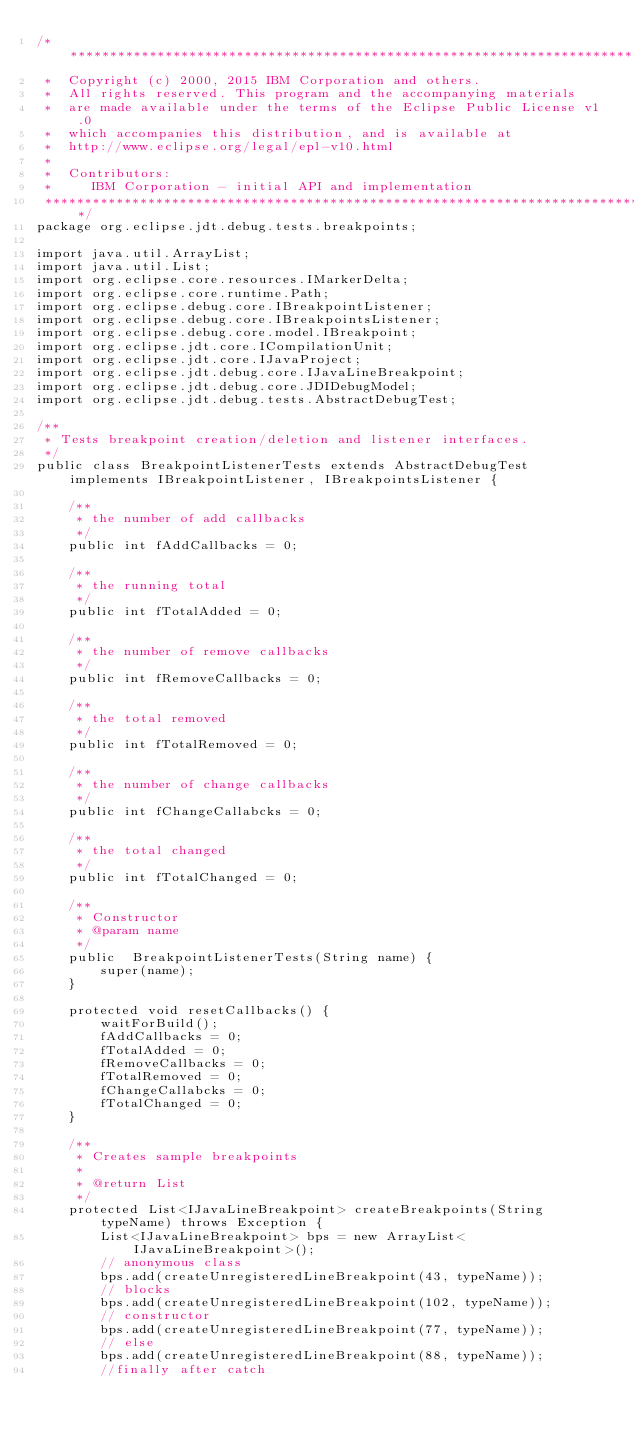<code> <loc_0><loc_0><loc_500><loc_500><_Java_>/*******************************************************************************
 *  Copyright (c) 2000, 2015 IBM Corporation and others.
 *  All rights reserved. This program and the accompanying materials
 *  are made available under the terms of the Eclipse Public License v1.0
 *  which accompanies this distribution, and is available at
 *  http://www.eclipse.org/legal/epl-v10.html
 * 
 *  Contributors:
 *     IBM Corporation - initial API and implementation
 *******************************************************************************/
package org.eclipse.jdt.debug.tests.breakpoints;

import java.util.ArrayList;
import java.util.List;
import org.eclipse.core.resources.IMarkerDelta;
import org.eclipse.core.runtime.Path;
import org.eclipse.debug.core.IBreakpointListener;
import org.eclipse.debug.core.IBreakpointsListener;
import org.eclipse.debug.core.model.IBreakpoint;
import org.eclipse.jdt.core.ICompilationUnit;
import org.eclipse.jdt.core.IJavaProject;
import org.eclipse.jdt.debug.core.IJavaLineBreakpoint;
import org.eclipse.jdt.debug.core.JDIDebugModel;
import org.eclipse.jdt.debug.tests.AbstractDebugTest;

/**
 * Tests breakpoint creation/deletion and listener interfaces.
 */
public class BreakpointListenerTests extends AbstractDebugTest implements IBreakpointListener, IBreakpointsListener {

    /**
	 * the number of add callbacks 
	 */
    public int fAddCallbacks = 0;

    /**
	 * the running total
	 */
    public int fTotalAdded = 0;

    /**
	 * the number of remove callbacks
	 */
    public int fRemoveCallbacks = 0;

    /**
	 * the total removed
	 */
    public int fTotalRemoved = 0;

    /**
	 * the number of change callbacks
	 */
    public int fChangeCallabcks = 0;

    /**
	 * the total changed
	 */
    public int fTotalChanged = 0;

    /**
	 * Constructor
	 * @param name
	 */
    public  BreakpointListenerTests(String name) {
        super(name);
    }

    protected void resetCallbacks() {
        waitForBuild();
        fAddCallbacks = 0;
        fTotalAdded = 0;
        fRemoveCallbacks = 0;
        fTotalRemoved = 0;
        fChangeCallabcks = 0;
        fTotalChanged = 0;
    }

    /**
	 * Creates sample breakpoints
	 * 
	 * @return List
	 */
    protected List<IJavaLineBreakpoint> createBreakpoints(String typeName) throws Exception {
        List<IJavaLineBreakpoint> bps = new ArrayList<IJavaLineBreakpoint>();
        // anonymous class
        bps.add(createUnregisteredLineBreakpoint(43, typeName));
        // blocks
        bps.add(createUnregisteredLineBreakpoint(102, typeName));
        // constructor
        bps.add(createUnregisteredLineBreakpoint(77, typeName));
        // else
        bps.add(createUnregisteredLineBreakpoint(88, typeName));
        //finally after catch</code> 